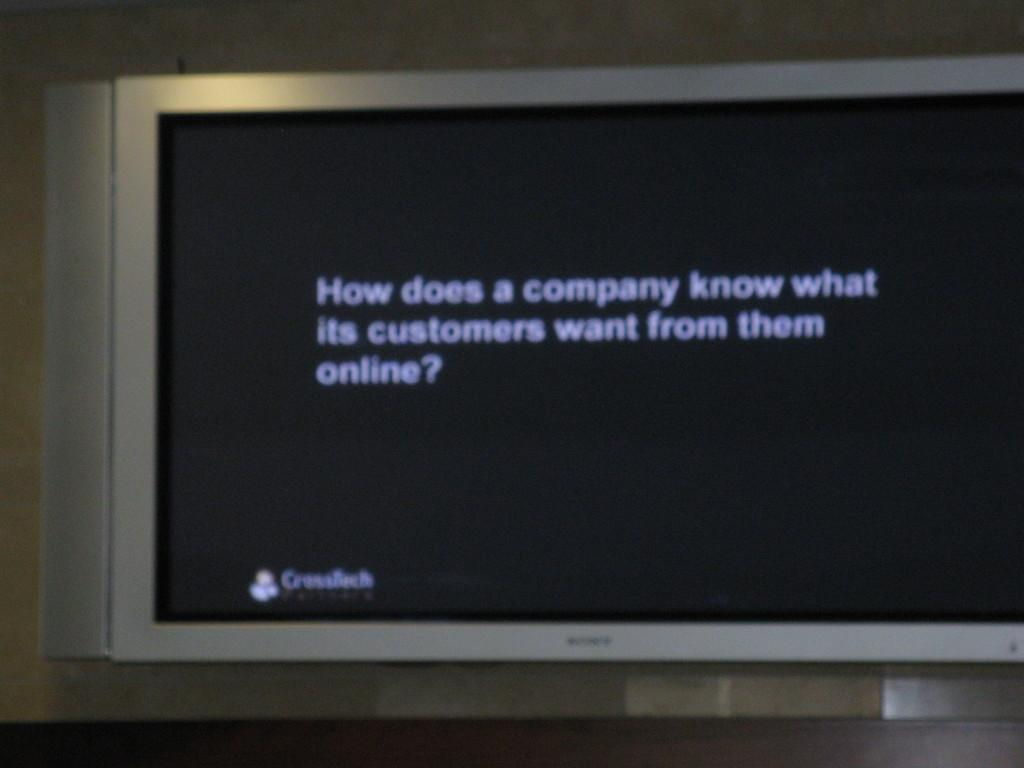<image>
Share a concise interpretation of the image provided. A TV screen shows a question about customer service. 